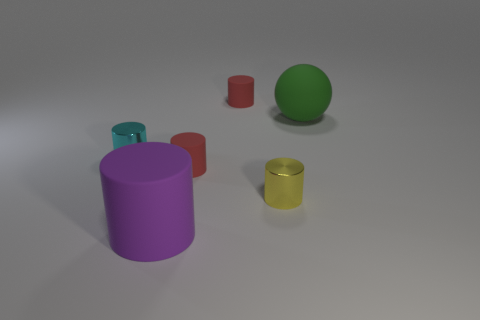What number of objects are yellow shiny cubes or rubber cylinders that are behind the big cylinder?
Offer a very short reply. 2. How big is the object that is both behind the tiny cyan object and to the left of the yellow metallic thing?
Provide a short and direct response. Small. Is the number of small yellow metallic things on the left side of the large purple thing greater than the number of red cylinders to the right of the large green sphere?
Provide a succinct answer. No. There is a tiny cyan metal object; does it have the same shape as the small red matte thing in front of the big green object?
Offer a very short reply. Yes. What number of other objects are there of the same shape as the green matte thing?
Your answer should be compact. 0. What is the color of the matte thing that is in front of the large green rubber sphere and right of the large purple object?
Provide a short and direct response. Red. The big cylinder is what color?
Your answer should be compact. Purple. Are the ball and the red cylinder that is in front of the large green object made of the same material?
Your response must be concise. Yes. What shape is the big object that is the same material as the large green sphere?
Keep it short and to the point. Cylinder. The ball that is the same size as the purple rubber object is what color?
Keep it short and to the point. Green. 